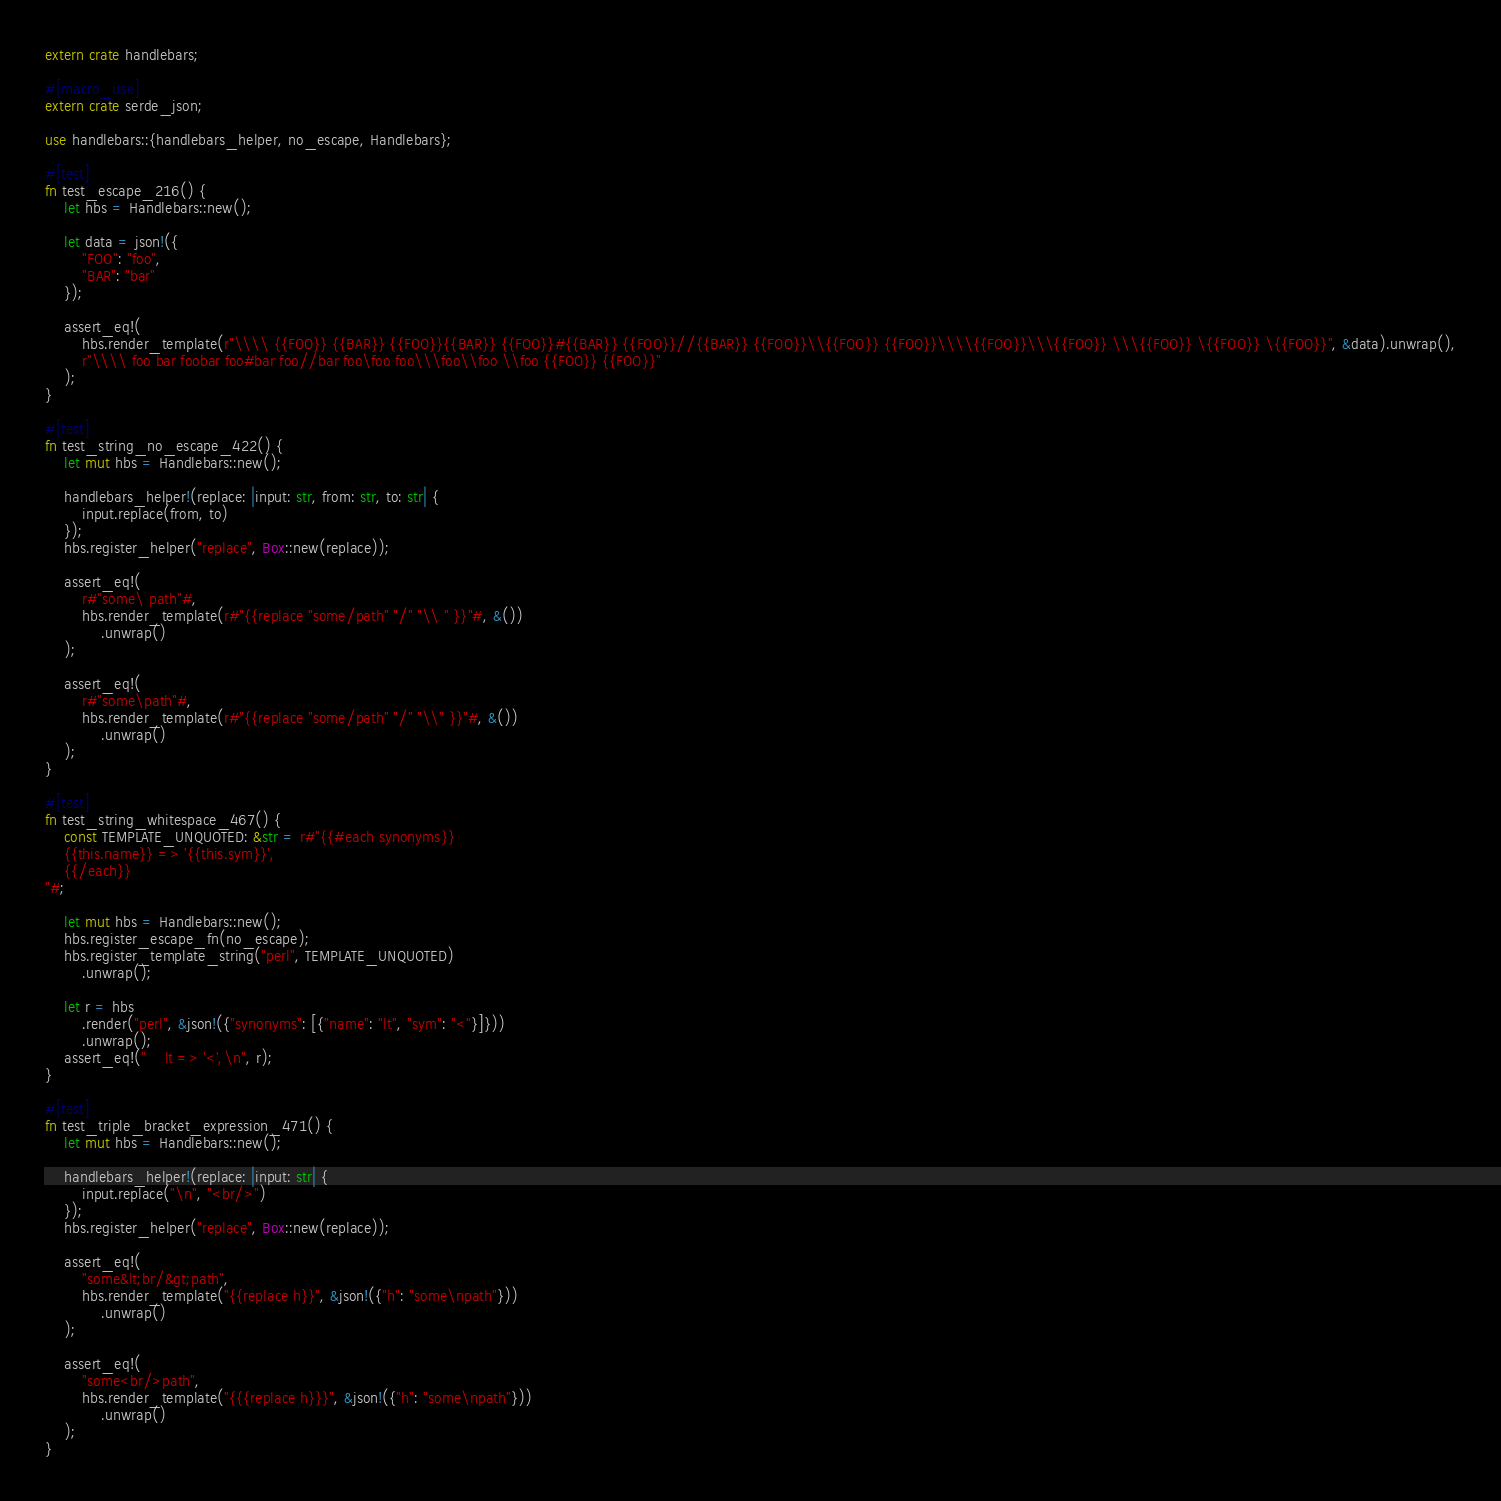Convert code to text. <code><loc_0><loc_0><loc_500><loc_500><_Rust_>extern crate handlebars;

#[macro_use]
extern crate serde_json;

use handlebars::{handlebars_helper, no_escape, Handlebars};

#[test]
fn test_escape_216() {
    let hbs = Handlebars::new();

    let data = json!({
        "FOO": "foo",
        "BAR": "bar"
    });

    assert_eq!(
        hbs.render_template(r"\\\\ {{FOO}} {{BAR}} {{FOO}}{{BAR}} {{FOO}}#{{BAR}} {{FOO}}//{{BAR}} {{FOO}}\\{{FOO}} {{FOO}}\\\\{{FOO}}\\\{{FOO}} \\\{{FOO}} \{{FOO}} \{{FOO}}", &data).unwrap(),
        r"\\\\ foo bar foobar foo#bar foo//bar foo\foo foo\\\foo\\foo \\foo {{FOO}} {{FOO}}"
    );
}

#[test]
fn test_string_no_escape_422() {
    let mut hbs = Handlebars::new();

    handlebars_helper!(replace: |input: str, from: str, to: str| {
        input.replace(from, to)
    });
    hbs.register_helper("replace", Box::new(replace));

    assert_eq!(
        r#"some\ path"#,
        hbs.render_template(r#"{{replace "some/path" "/" "\\ " }}"#, &())
            .unwrap()
    );

    assert_eq!(
        r#"some\path"#,
        hbs.render_template(r#"{{replace "some/path" "/" "\\" }}"#, &())
            .unwrap()
    );
}

#[test]
fn test_string_whitespace_467() {
    const TEMPLATE_UNQUOTED: &str = r#"{{#each synonyms}}
    {{this.name}} => '{{this.sym}}',
    {{/each}}
"#;

    let mut hbs = Handlebars::new();
    hbs.register_escape_fn(no_escape);
    hbs.register_template_string("perl", TEMPLATE_UNQUOTED)
        .unwrap();

    let r = hbs
        .render("perl", &json!({"synonyms": [{"name": "lt", "sym": "<"}]}))
        .unwrap();
    assert_eq!("    lt => '<',\n", r);
}

#[test]
fn test_triple_bracket_expression_471() {
    let mut hbs = Handlebars::new();

    handlebars_helper!(replace: |input: str| {
        input.replace("\n", "<br/>")
    });
    hbs.register_helper("replace", Box::new(replace));

    assert_eq!(
        "some&lt;br/&gt;path",
        hbs.render_template("{{replace h}}", &json!({"h": "some\npath"}))
            .unwrap()
    );

    assert_eq!(
        "some<br/>path",
        hbs.render_template("{{{replace h}}}", &json!({"h": "some\npath"}))
            .unwrap()
    );
}
</code> 